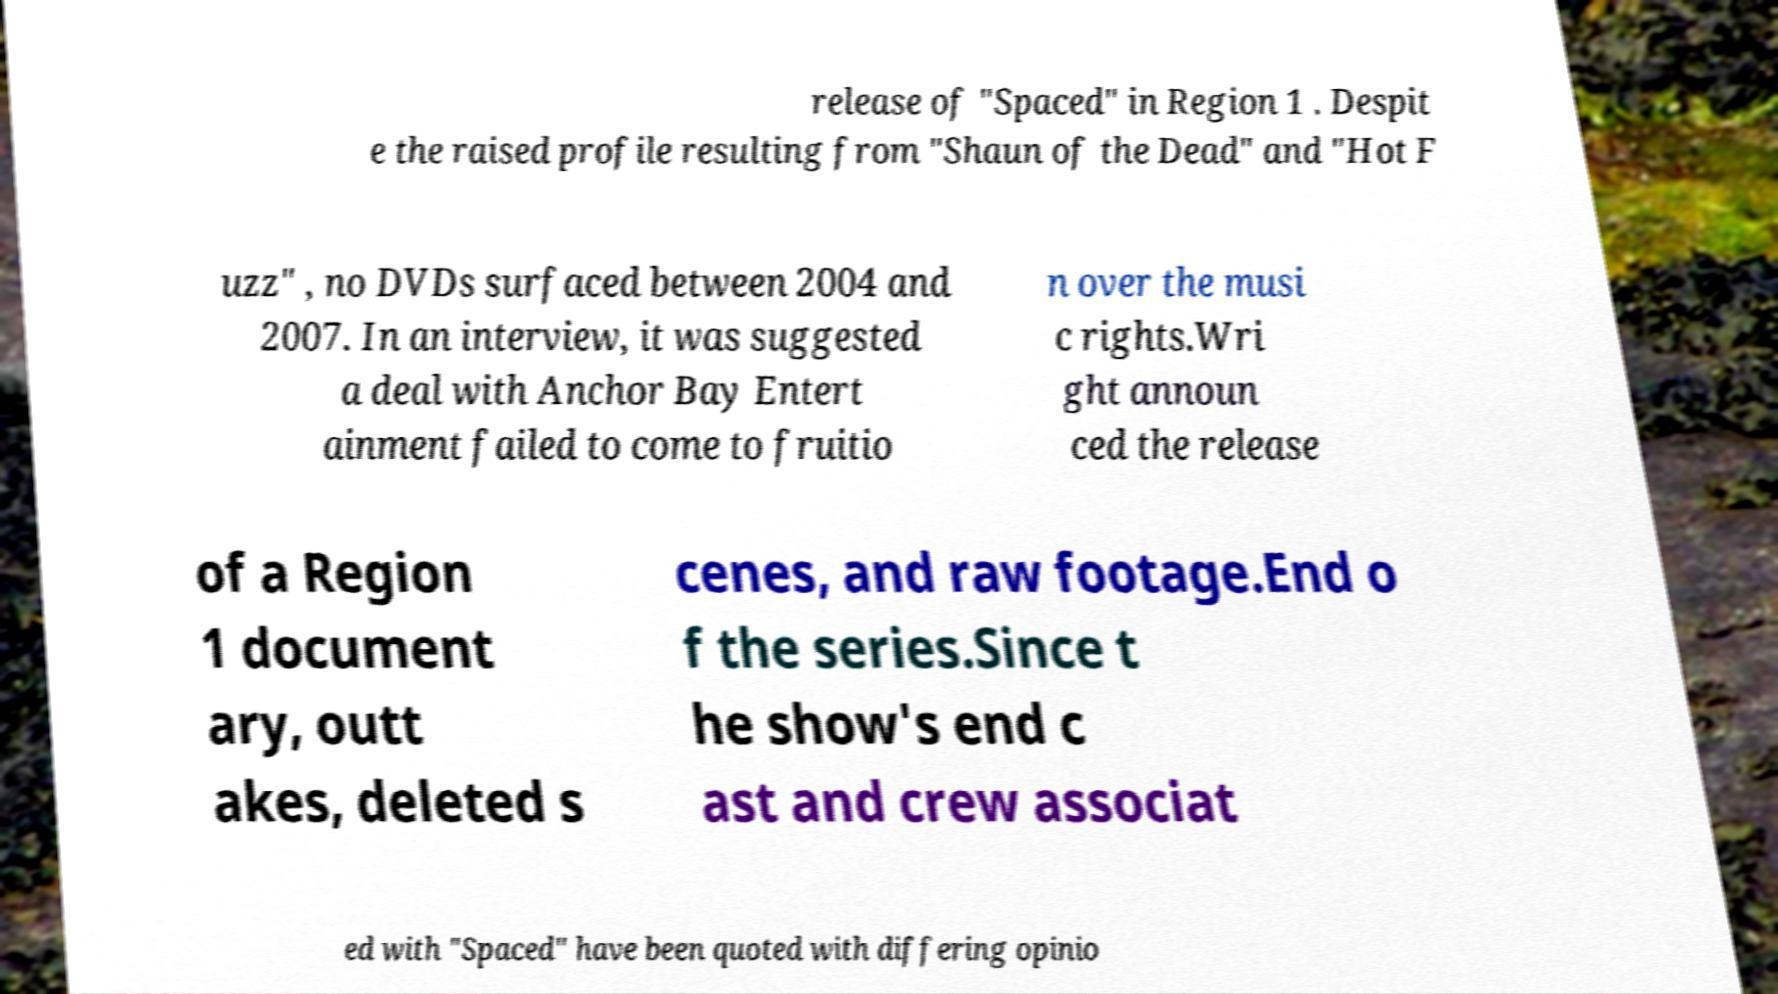What messages or text are displayed in this image? I need them in a readable, typed format. release of "Spaced" in Region 1 . Despit e the raised profile resulting from "Shaun of the Dead" and "Hot F uzz" , no DVDs surfaced between 2004 and 2007. In an interview, it was suggested a deal with Anchor Bay Entert ainment failed to come to fruitio n over the musi c rights.Wri ght announ ced the release of a Region 1 document ary, outt akes, deleted s cenes, and raw footage.End o f the series.Since t he show's end c ast and crew associat ed with "Spaced" have been quoted with differing opinio 